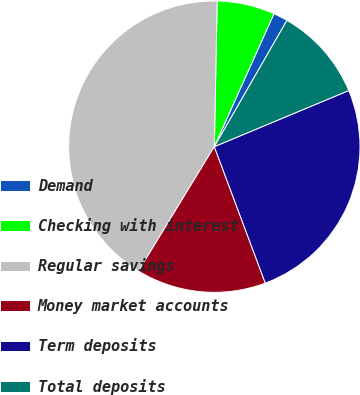Convert chart to OTSL. <chart><loc_0><loc_0><loc_500><loc_500><pie_chart><fcel>Demand<fcel>Checking with interest<fcel>Regular savings<fcel>Money market accounts<fcel>Term deposits<fcel>Total deposits<nl><fcel>1.6%<fcel>6.4%<fcel>41.6%<fcel>14.4%<fcel>25.6%<fcel>10.4%<nl></chart> 